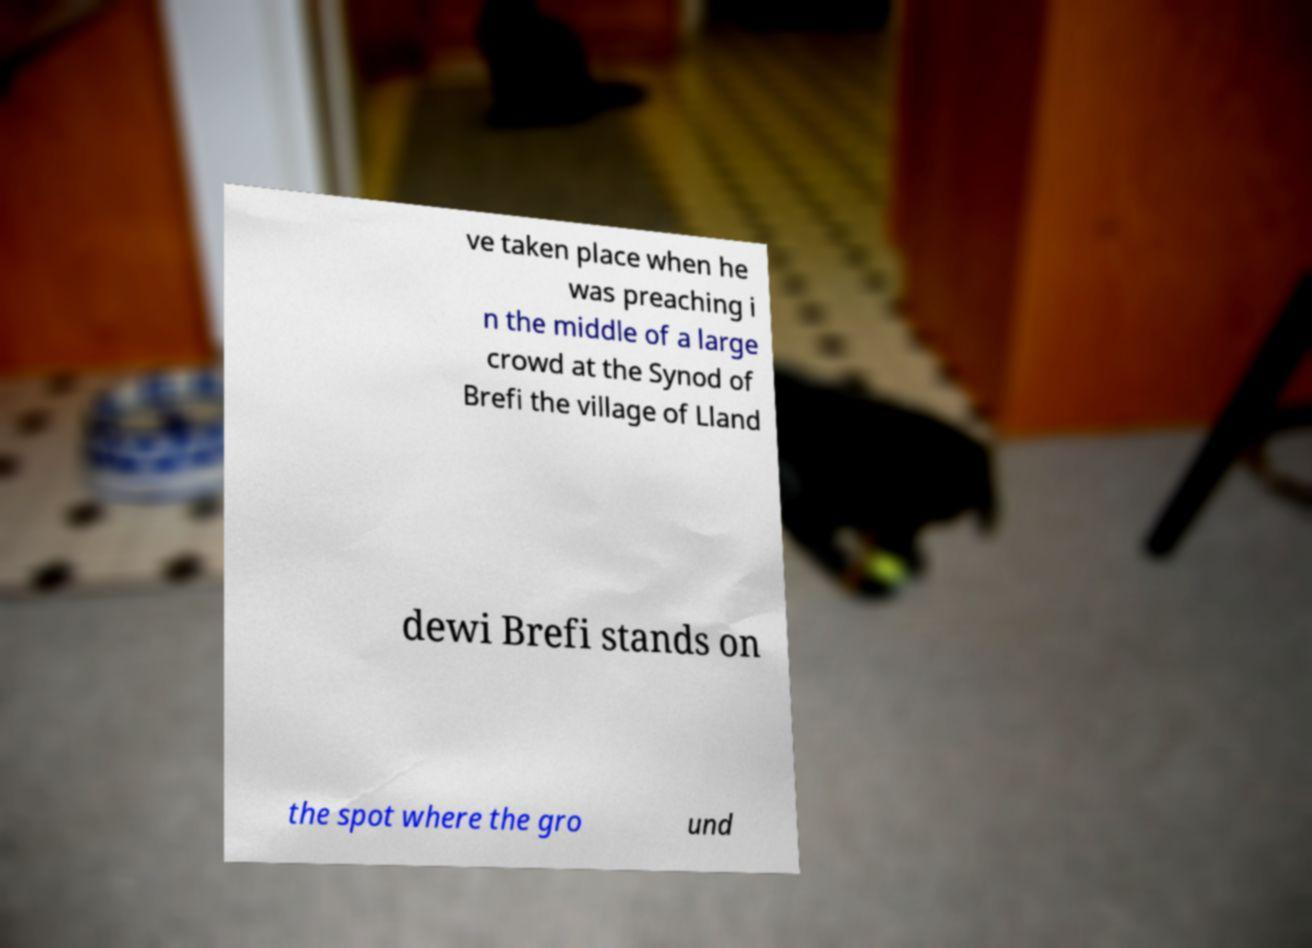For documentation purposes, I need the text within this image transcribed. Could you provide that? ve taken place when he was preaching i n the middle of a large crowd at the Synod of Brefi the village of Lland dewi Brefi stands on the spot where the gro und 